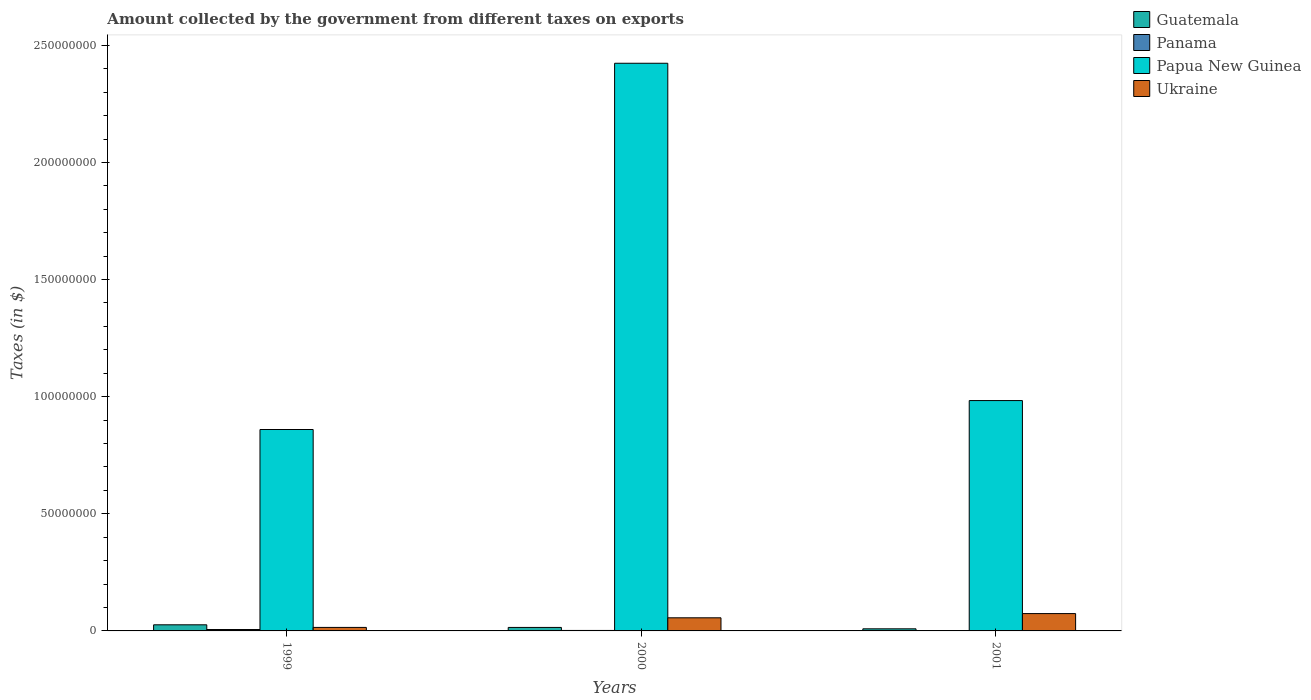How many different coloured bars are there?
Give a very brief answer. 4. How many groups of bars are there?
Offer a very short reply. 3. Are the number of bars per tick equal to the number of legend labels?
Your response must be concise. Yes. Are the number of bars on each tick of the X-axis equal?
Ensure brevity in your answer.  Yes. In how many cases, is the number of bars for a given year not equal to the number of legend labels?
Provide a short and direct response. 0. What is the amount collected by the government from taxes on exports in Papua New Guinea in 2000?
Your answer should be compact. 2.42e+08. Across all years, what is the maximum amount collected by the government from taxes on exports in Papua New Guinea?
Provide a short and direct response. 2.42e+08. In which year was the amount collected by the government from taxes on exports in Ukraine maximum?
Your answer should be compact. 2001. What is the total amount collected by the government from taxes on exports in Papua New Guinea in the graph?
Keep it short and to the point. 4.27e+08. What is the difference between the amount collected by the government from taxes on exports in Ukraine in 2000 and that in 2001?
Provide a succinct answer. -1.80e+06. What is the difference between the amount collected by the government from taxes on exports in Guatemala in 2001 and the amount collected by the government from taxes on exports in Papua New Guinea in 1999?
Keep it short and to the point. -8.51e+07. What is the average amount collected by the government from taxes on exports in Guatemala per year?
Provide a short and direct response. 1.67e+06. In the year 1999, what is the difference between the amount collected by the government from taxes on exports in Papua New Guinea and amount collected by the government from taxes on exports in Guatemala?
Provide a succinct answer. 8.34e+07. What is the ratio of the amount collected by the government from taxes on exports in Panama in 2000 to that in 2001?
Ensure brevity in your answer.  5. Is the difference between the amount collected by the government from taxes on exports in Papua New Guinea in 1999 and 2001 greater than the difference between the amount collected by the government from taxes on exports in Guatemala in 1999 and 2001?
Keep it short and to the point. No. What is the difference between the highest and the second highest amount collected by the government from taxes on exports in Papua New Guinea?
Ensure brevity in your answer.  1.44e+08. What is the difference between the highest and the lowest amount collected by the government from taxes on exports in Guatemala?
Provide a succinct answer. 1.71e+06. In how many years, is the amount collected by the government from taxes on exports in Papua New Guinea greater than the average amount collected by the government from taxes on exports in Papua New Guinea taken over all years?
Give a very brief answer. 1. What does the 1st bar from the left in 2001 represents?
Offer a terse response. Guatemala. What does the 1st bar from the right in 2001 represents?
Offer a very short reply. Ukraine. Is it the case that in every year, the sum of the amount collected by the government from taxes on exports in Panama and amount collected by the government from taxes on exports in Ukraine is greater than the amount collected by the government from taxes on exports in Papua New Guinea?
Provide a short and direct response. No. How many bars are there?
Your answer should be compact. 12. What is the difference between two consecutive major ticks on the Y-axis?
Provide a succinct answer. 5.00e+07. Does the graph contain any zero values?
Offer a terse response. No. Does the graph contain grids?
Give a very brief answer. No. Where does the legend appear in the graph?
Ensure brevity in your answer.  Top right. How are the legend labels stacked?
Your response must be concise. Vertical. What is the title of the graph?
Your response must be concise. Amount collected by the government from different taxes on exports. What is the label or title of the Y-axis?
Offer a very short reply. Taxes (in $). What is the Taxes (in $) in Guatemala in 1999?
Keep it short and to the point. 2.61e+06. What is the Taxes (in $) in Panama in 1999?
Give a very brief answer. 6.00e+05. What is the Taxes (in $) of Papua New Guinea in 1999?
Keep it short and to the point. 8.60e+07. What is the Taxes (in $) of Ukraine in 1999?
Keep it short and to the point. 1.50e+06. What is the Taxes (in $) of Guatemala in 2000?
Ensure brevity in your answer.  1.49e+06. What is the Taxes (in $) of Panama in 2000?
Ensure brevity in your answer.  2.00e+05. What is the Taxes (in $) of Papua New Guinea in 2000?
Make the answer very short. 2.42e+08. What is the Taxes (in $) of Ukraine in 2000?
Your response must be concise. 5.60e+06. What is the Taxes (in $) of Papua New Guinea in 2001?
Offer a terse response. 9.83e+07. What is the Taxes (in $) in Ukraine in 2001?
Give a very brief answer. 7.40e+06. Across all years, what is the maximum Taxes (in $) of Guatemala?
Give a very brief answer. 2.61e+06. Across all years, what is the maximum Taxes (in $) of Papua New Guinea?
Your answer should be compact. 2.42e+08. Across all years, what is the maximum Taxes (in $) of Ukraine?
Your answer should be very brief. 7.40e+06. Across all years, what is the minimum Taxes (in $) of Guatemala?
Provide a succinct answer. 9.00e+05. Across all years, what is the minimum Taxes (in $) of Papua New Guinea?
Your response must be concise. 8.60e+07. Across all years, what is the minimum Taxes (in $) of Ukraine?
Provide a succinct answer. 1.50e+06. What is the total Taxes (in $) of Guatemala in the graph?
Make the answer very short. 5.00e+06. What is the total Taxes (in $) of Panama in the graph?
Provide a short and direct response. 8.40e+05. What is the total Taxes (in $) of Papua New Guinea in the graph?
Provide a succinct answer. 4.27e+08. What is the total Taxes (in $) in Ukraine in the graph?
Provide a succinct answer. 1.45e+07. What is the difference between the Taxes (in $) in Guatemala in 1999 and that in 2000?
Offer a terse response. 1.12e+06. What is the difference between the Taxes (in $) of Papua New Guinea in 1999 and that in 2000?
Ensure brevity in your answer.  -1.56e+08. What is the difference between the Taxes (in $) of Ukraine in 1999 and that in 2000?
Keep it short and to the point. -4.10e+06. What is the difference between the Taxes (in $) in Guatemala in 1999 and that in 2001?
Provide a succinct answer. 1.71e+06. What is the difference between the Taxes (in $) in Panama in 1999 and that in 2001?
Keep it short and to the point. 5.60e+05. What is the difference between the Taxes (in $) in Papua New Guinea in 1999 and that in 2001?
Your answer should be very brief. -1.24e+07. What is the difference between the Taxes (in $) of Ukraine in 1999 and that in 2001?
Give a very brief answer. -5.90e+06. What is the difference between the Taxes (in $) in Guatemala in 2000 and that in 2001?
Provide a short and direct response. 5.90e+05. What is the difference between the Taxes (in $) in Papua New Guinea in 2000 and that in 2001?
Make the answer very short. 1.44e+08. What is the difference between the Taxes (in $) of Ukraine in 2000 and that in 2001?
Ensure brevity in your answer.  -1.80e+06. What is the difference between the Taxes (in $) in Guatemala in 1999 and the Taxes (in $) in Panama in 2000?
Ensure brevity in your answer.  2.41e+06. What is the difference between the Taxes (in $) of Guatemala in 1999 and the Taxes (in $) of Papua New Guinea in 2000?
Offer a terse response. -2.40e+08. What is the difference between the Taxes (in $) of Guatemala in 1999 and the Taxes (in $) of Ukraine in 2000?
Your answer should be compact. -2.99e+06. What is the difference between the Taxes (in $) in Panama in 1999 and the Taxes (in $) in Papua New Guinea in 2000?
Provide a succinct answer. -2.42e+08. What is the difference between the Taxes (in $) in Panama in 1999 and the Taxes (in $) in Ukraine in 2000?
Make the answer very short. -5.00e+06. What is the difference between the Taxes (in $) of Papua New Guinea in 1999 and the Taxes (in $) of Ukraine in 2000?
Keep it short and to the point. 8.04e+07. What is the difference between the Taxes (in $) in Guatemala in 1999 and the Taxes (in $) in Panama in 2001?
Ensure brevity in your answer.  2.57e+06. What is the difference between the Taxes (in $) of Guatemala in 1999 and the Taxes (in $) of Papua New Guinea in 2001?
Give a very brief answer. -9.57e+07. What is the difference between the Taxes (in $) in Guatemala in 1999 and the Taxes (in $) in Ukraine in 2001?
Your response must be concise. -4.79e+06. What is the difference between the Taxes (in $) in Panama in 1999 and the Taxes (in $) in Papua New Guinea in 2001?
Make the answer very short. -9.77e+07. What is the difference between the Taxes (in $) in Panama in 1999 and the Taxes (in $) in Ukraine in 2001?
Provide a succinct answer. -6.80e+06. What is the difference between the Taxes (in $) of Papua New Guinea in 1999 and the Taxes (in $) of Ukraine in 2001?
Provide a short and direct response. 7.86e+07. What is the difference between the Taxes (in $) in Guatemala in 2000 and the Taxes (in $) in Panama in 2001?
Make the answer very short. 1.45e+06. What is the difference between the Taxes (in $) in Guatemala in 2000 and the Taxes (in $) in Papua New Guinea in 2001?
Provide a succinct answer. -9.69e+07. What is the difference between the Taxes (in $) of Guatemala in 2000 and the Taxes (in $) of Ukraine in 2001?
Ensure brevity in your answer.  -5.91e+06. What is the difference between the Taxes (in $) in Panama in 2000 and the Taxes (in $) in Papua New Guinea in 2001?
Make the answer very short. -9.81e+07. What is the difference between the Taxes (in $) in Panama in 2000 and the Taxes (in $) in Ukraine in 2001?
Your answer should be very brief. -7.20e+06. What is the difference between the Taxes (in $) in Papua New Guinea in 2000 and the Taxes (in $) in Ukraine in 2001?
Offer a terse response. 2.35e+08. What is the average Taxes (in $) of Guatemala per year?
Keep it short and to the point. 1.67e+06. What is the average Taxes (in $) of Panama per year?
Give a very brief answer. 2.80e+05. What is the average Taxes (in $) of Papua New Guinea per year?
Your response must be concise. 1.42e+08. What is the average Taxes (in $) in Ukraine per year?
Your answer should be very brief. 4.83e+06. In the year 1999, what is the difference between the Taxes (in $) in Guatemala and Taxes (in $) in Panama?
Give a very brief answer. 2.01e+06. In the year 1999, what is the difference between the Taxes (in $) in Guatemala and Taxes (in $) in Papua New Guinea?
Provide a succinct answer. -8.34e+07. In the year 1999, what is the difference between the Taxes (in $) of Guatemala and Taxes (in $) of Ukraine?
Keep it short and to the point. 1.11e+06. In the year 1999, what is the difference between the Taxes (in $) of Panama and Taxes (in $) of Papua New Guinea?
Your answer should be very brief. -8.54e+07. In the year 1999, what is the difference between the Taxes (in $) of Panama and Taxes (in $) of Ukraine?
Give a very brief answer. -9.00e+05. In the year 1999, what is the difference between the Taxes (in $) of Papua New Guinea and Taxes (in $) of Ukraine?
Provide a short and direct response. 8.45e+07. In the year 2000, what is the difference between the Taxes (in $) in Guatemala and Taxes (in $) in Panama?
Your answer should be compact. 1.29e+06. In the year 2000, what is the difference between the Taxes (in $) in Guatemala and Taxes (in $) in Papua New Guinea?
Offer a very short reply. -2.41e+08. In the year 2000, what is the difference between the Taxes (in $) of Guatemala and Taxes (in $) of Ukraine?
Your response must be concise. -4.11e+06. In the year 2000, what is the difference between the Taxes (in $) in Panama and Taxes (in $) in Papua New Guinea?
Provide a short and direct response. -2.42e+08. In the year 2000, what is the difference between the Taxes (in $) in Panama and Taxes (in $) in Ukraine?
Offer a very short reply. -5.40e+06. In the year 2000, what is the difference between the Taxes (in $) in Papua New Guinea and Taxes (in $) in Ukraine?
Your answer should be very brief. 2.37e+08. In the year 2001, what is the difference between the Taxes (in $) in Guatemala and Taxes (in $) in Panama?
Keep it short and to the point. 8.60e+05. In the year 2001, what is the difference between the Taxes (in $) in Guatemala and Taxes (in $) in Papua New Guinea?
Offer a terse response. -9.74e+07. In the year 2001, what is the difference between the Taxes (in $) in Guatemala and Taxes (in $) in Ukraine?
Your answer should be very brief. -6.50e+06. In the year 2001, what is the difference between the Taxes (in $) in Panama and Taxes (in $) in Papua New Guinea?
Ensure brevity in your answer.  -9.83e+07. In the year 2001, what is the difference between the Taxes (in $) of Panama and Taxes (in $) of Ukraine?
Offer a terse response. -7.36e+06. In the year 2001, what is the difference between the Taxes (in $) in Papua New Guinea and Taxes (in $) in Ukraine?
Make the answer very short. 9.09e+07. What is the ratio of the Taxes (in $) in Guatemala in 1999 to that in 2000?
Give a very brief answer. 1.75. What is the ratio of the Taxes (in $) in Panama in 1999 to that in 2000?
Your answer should be very brief. 3. What is the ratio of the Taxes (in $) of Papua New Guinea in 1999 to that in 2000?
Offer a very short reply. 0.35. What is the ratio of the Taxes (in $) in Ukraine in 1999 to that in 2000?
Give a very brief answer. 0.27. What is the ratio of the Taxes (in $) of Papua New Guinea in 1999 to that in 2001?
Give a very brief answer. 0.87. What is the ratio of the Taxes (in $) of Ukraine in 1999 to that in 2001?
Your answer should be very brief. 0.2. What is the ratio of the Taxes (in $) of Guatemala in 2000 to that in 2001?
Provide a short and direct response. 1.66. What is the ratio of the Taxes (in $) in Papua New Guinea in 2000 to that in 2001?
Your answer should be compact. 2.46. What is the ratio of the Taxes (in $) in Ukraine in 2000 to that in 2001?
Provide a short and direct response. 0.76. What is the difference between the highest and the second highest Taxes (in $) in Guatemala?
Your response must be concise. 1.12e+06. What is the difference between the highest and the second highest Taxes (in $) in Panama?
Offer a very short reply. 4.00e+05. What is the difference between the highest and the second highest Taxes (in $) in Papua New Guinea?
Keep it short and to the point. 1.44e+08. What is the difference between the highest and the second highest Taxes (in $) in Ukraine?
Offer a very short reply. 1.80e+06. What is the difference between the highest and the lowest Taxes (in $) of Guatemala?
Your answer should be very brief. 1.71e+06. What is the difference between the highest and the lowest Taxes (in $) of Panama?
Your response must be concise. 5.60e+05. What is the difference between the highest and the lowest Taxes (in $) in Papua New Guinea?
Offer a very short reply. 1.56e+08. What is the difference between the highest and the lowest Taxes (in $) of Ukraine?
Provide a short and direct response. 5.90e+06. 